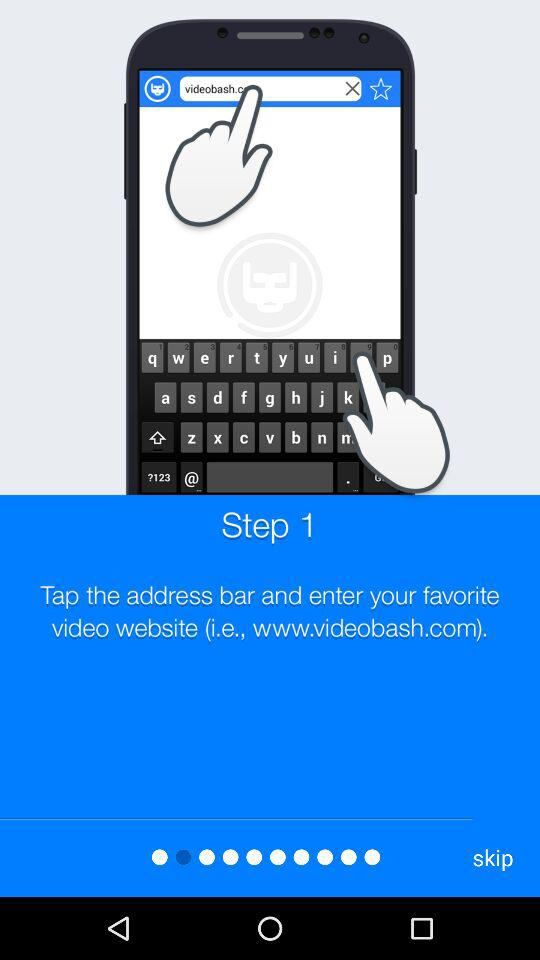How many steps are there in this tutorial?
Answer the question using a single word or phrase. 1 